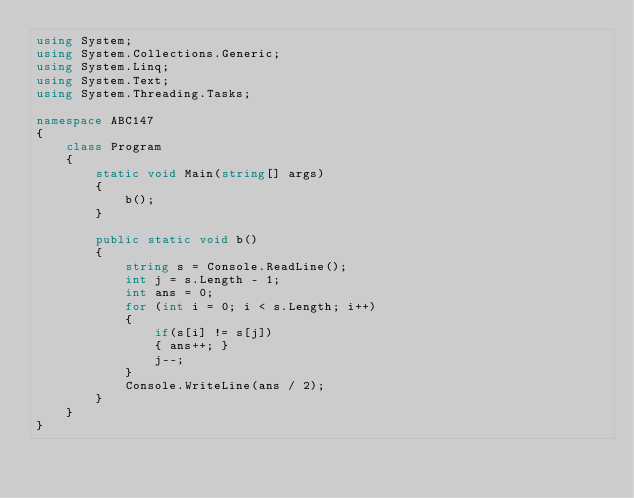Convert code to text. <code><loc_0><loc_0><loc_500><loc_500><_C#_>using System;
using System.Collections.Generic;
using System.Linq;
using System.Text;
using System.Threading.Tasks;

namespace ABC147
{
    class Program
    {
        static void Main(string[] args)
        {
            b();
        }

        public static void b()
        {
            string s = Console.ReadLine();
            int j = s.Length - 1;
            int ans = 0;
            for (int i = 0; i < s.Length; i++)
            {
                if(s[i] != s[j])
                { ans++; }
                j--;
            }
            Console.WriteLine(ans / 2);
        }
    }
}
</code> 